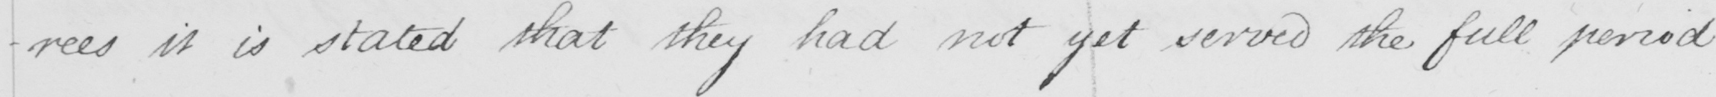Can you tell me what this handwritten text says? -rees it is stated that they had not yet served the full period 